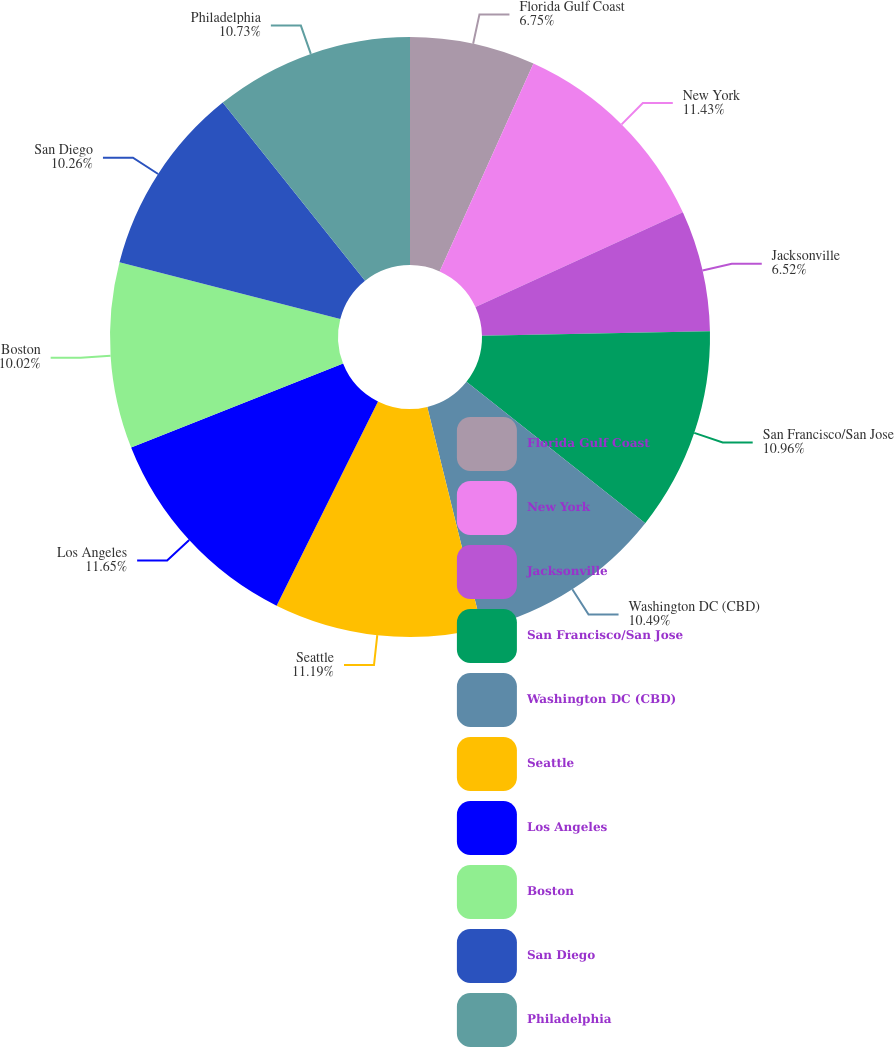<chart> <loc_0><loc_0><loc_500><loc_500><pie_chart><fcel>Florida Gulf Coast<fcel>New York<fcel>Jacksonville<fcel>San Francisco/San Jose<fcel>Washington DC (CBD)<fcel>Seattle<fcel>Los Angeles<fcel>Boston<fcel>San Diego<fcel>Philadelphia<nl><fcel>6.75%<fcel>11.43%<fcel>6.52%<fcel>10.96%<fcel>10.49%<fcel>11.19%<fcel>11.66%<fcel>10.02%<fcel>10.26%<fcel>10.73%<nl></chart> 